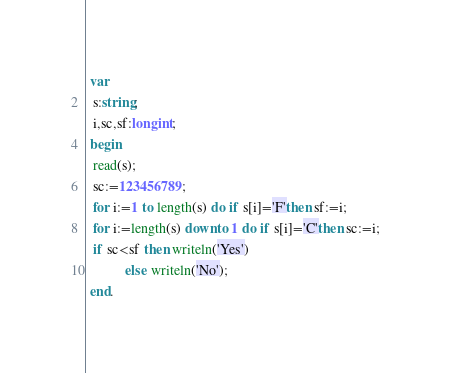Convert code to text. <code><loc_0><loc_0><loc_500><loc_500><_Pascal_> var
  s:string;
  i,sc,sf:longint; 
 begin
  read(s);
  sc:=123456789;
  for i:=1 to length(s) do if s[i]='F'then sf:=i; 
  for i:=length(s) downto 1 do if s[i]='C'then sc:=i;
  if sc<sf then writeln('Yes')
           else writeln('No');
 end.</code> 